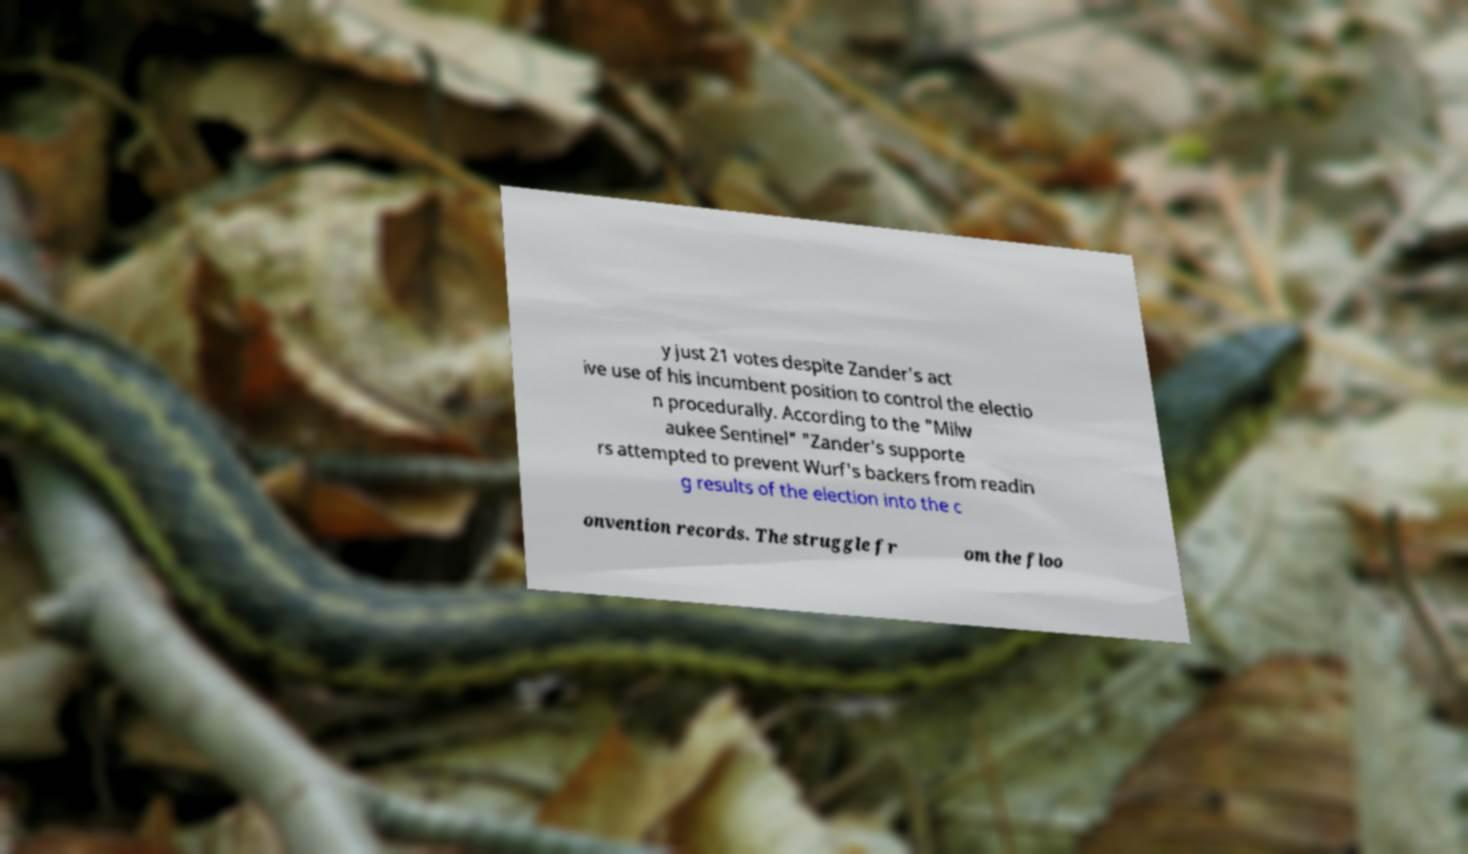What might be the significance of this document related to an election? This document appears to be detailing an incident that occurred during an election process where there was a narrow vote difference and some procedural controversy. It suggests a contentious political climate and hints at disputes regarding electoral integrity or potential manipulations. 